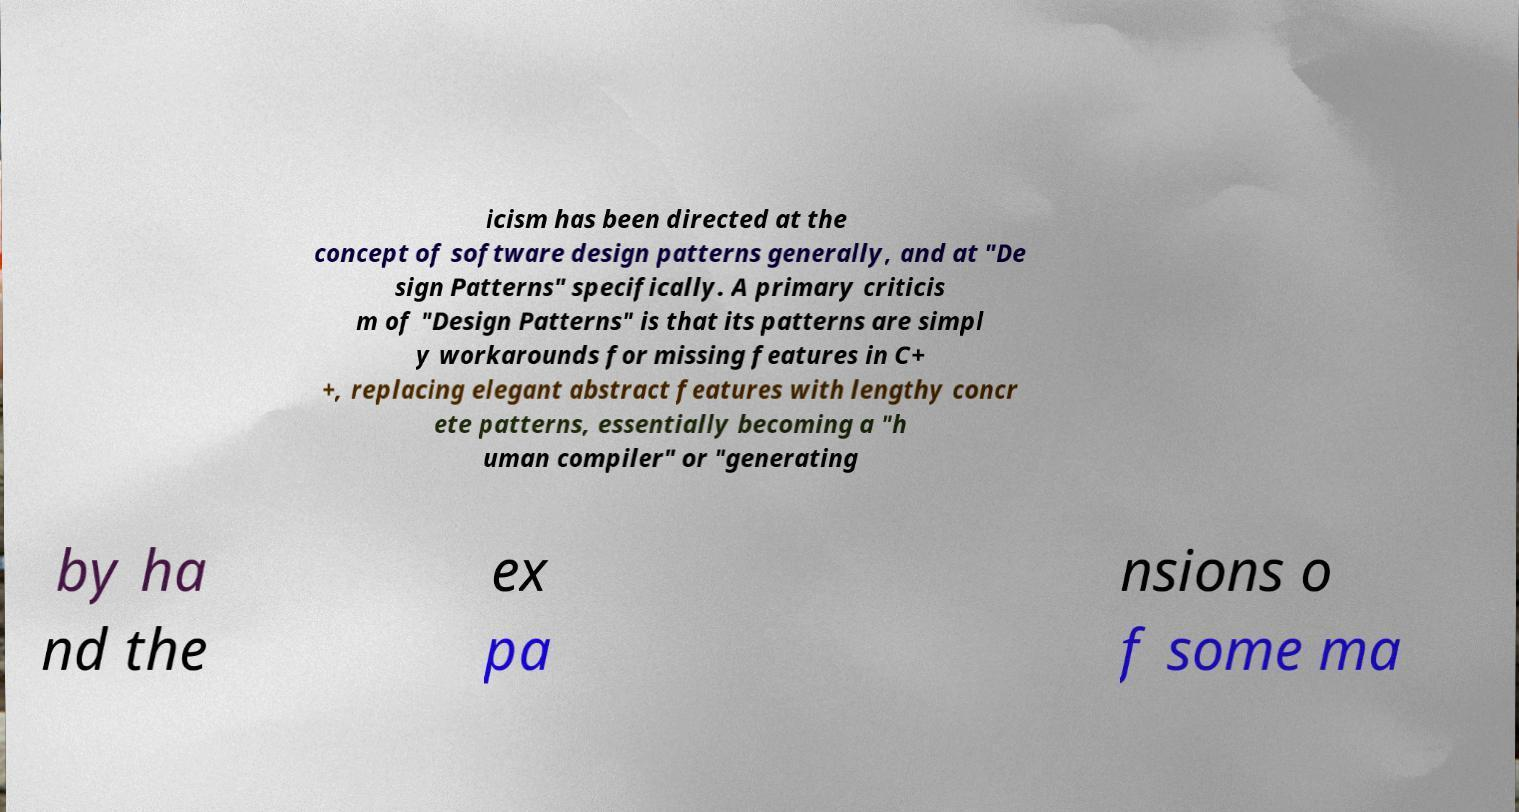Please identify and transcribe the text found in this image. icism has been directed at the concept of software design patterns generally, and at "De sign Patterns" specifically. A primary criticis m of "Design Patterns" is that its patterns are simpl y workarounds for missing features in C+ +, replacing elegant abstract features with lengthy concr ete patterns, essentially becoming a "h uman compiler" or "generating by ha nd the ex pa nsions o f some ma 